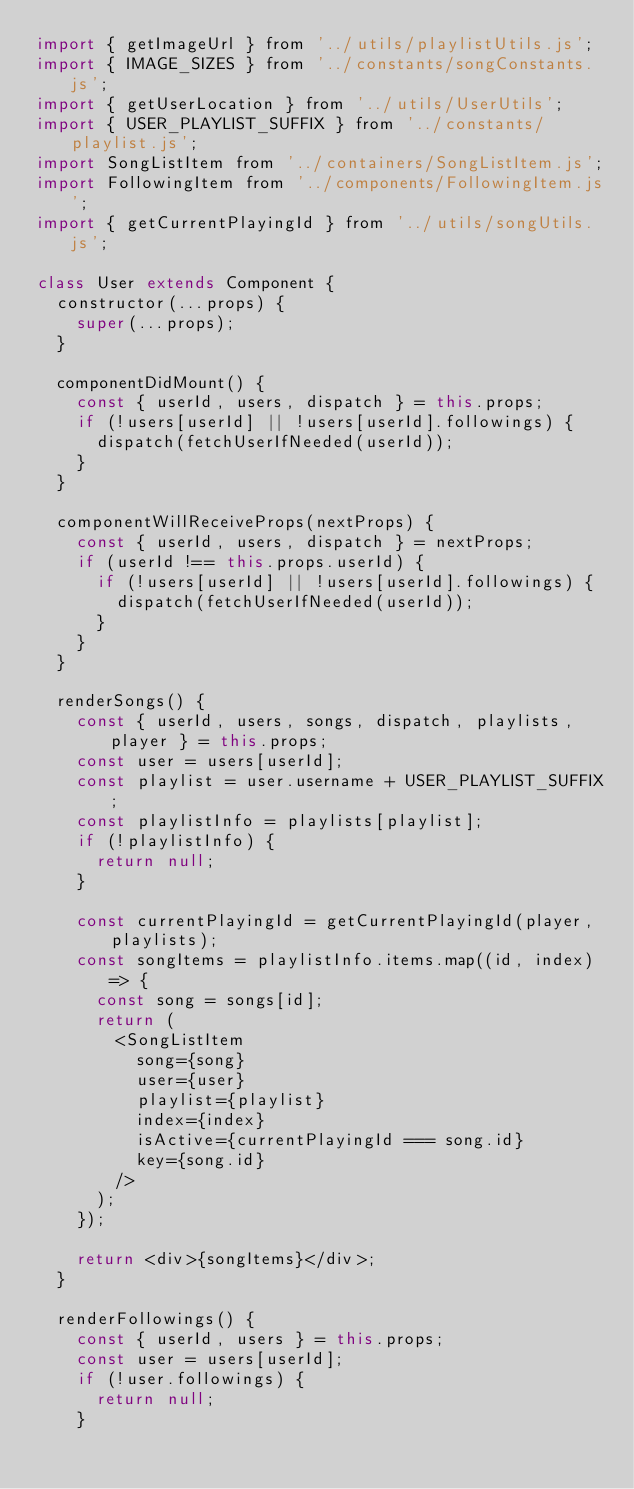Convert code to text. <code><loc_0><loc_0><loc_500><loc_500><_JavaScript_>import { getImageUrl } from '../utils/playlistUtils.js';
import { IMAGE_SIZES } from '../constants/songConstants.js';
import { getUserLocation } from '../utils/UserUtils';
import { USER_PLAYLIST_SUFFIX } from '../constants/playlist.js';
import SongListItem from '../containers/SongListItem.js';
import FollowingItem from '../components/FollowingItem.js';
import { getCurrentPlayingId } from '../utils/songUtils.js';

class User extends Component {
  constructor(...props) {
    super(...props);
  }

  componentDidMount() {
    const { userId, users, dispatch } = this.props;
    if (!users[userId] || !users[userId].followings) {
      dispatch(fetchUserIfNeeded(userId));
    }
  }

  componentWillReceiveProps(nextProps) {
    const { userId, users, dispatch } = nextProps;
    if (userId !== this.props.userId) {
      if (!users[userId] || !users[userId].followings) {
        dispatch(fetchUserIfNeeded(userId));
      }
    }
  }

  renderSongs() {
    const { userId, users, songs, dispatch, playlists, player } = this.props;
    const user = users[userId];
    const playlist = user.username + USER_PLAYLIST_SUFFIX;
    const playlistInfo = playlists[playlist];
    if (!playlistInfo) {
      return null;
    }

    const currentPlayingId = getCurrentPlayingId(player, playlists);
    const songItems = playlistInfo.items.map((id, index) => {
      const song = songs[id];
      return (
        <SongListItem
          song={song}
          user={user}
          playlist={playlist}
          index={index}
          isActive={currentPlayingId === song.id}
          key={song.id}
        />
      );
    });

    return <div>{songItems}</div>;
  }

  renderFollowings() {
    const { userId, users } = this.props;
    const user = users[userId];
    if (!user.followings) {
      return null;
    }
</code> 